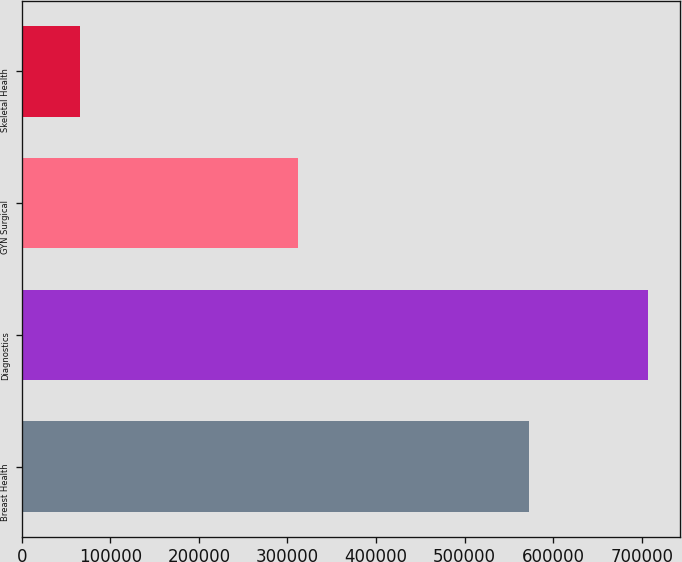Convert chart to OTSL. <chart><loc_0><loc_0><loc_500><loc_500><bar_chart><fcel>Breast Health<fcel>Diagnostics<fcel>GYN Surgical<fcel>Skeletal Health<nl><fcel>572485<fcel>707529<fcel>311643<fcel>66071<nl></chart> 